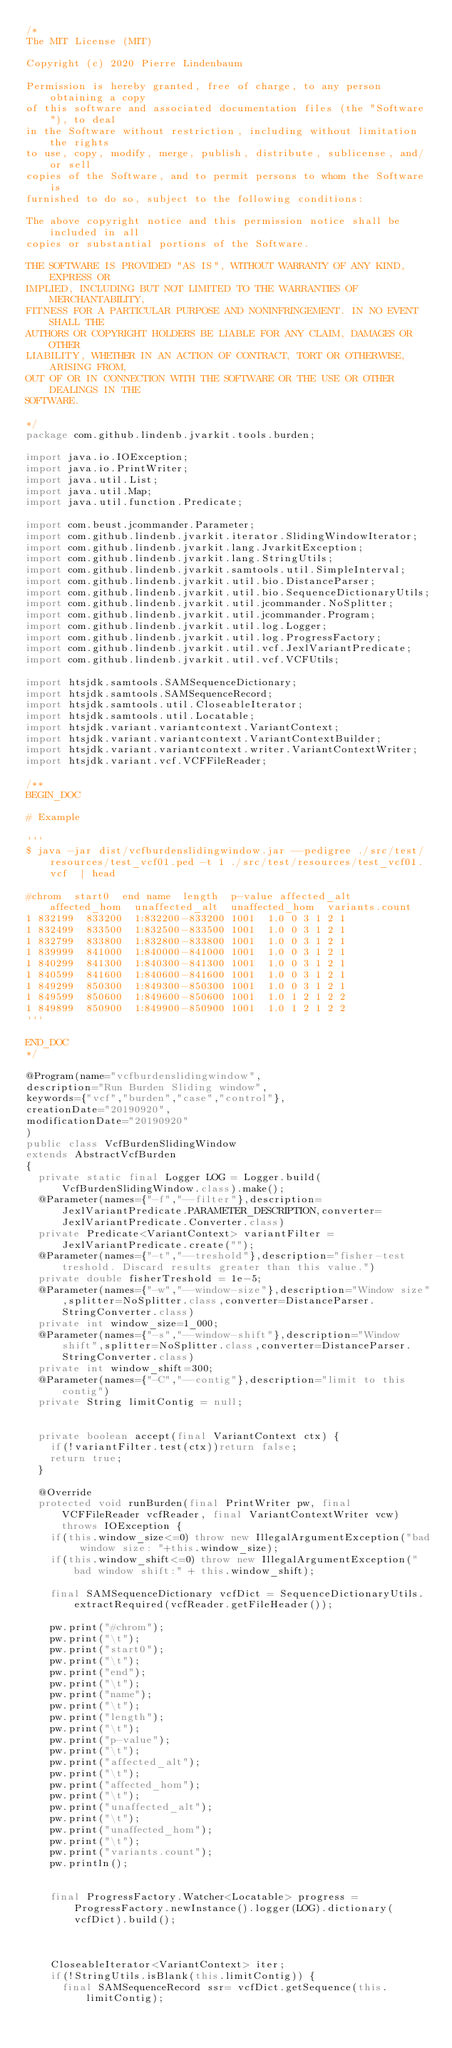<code> <loc_0><loc_0><loc_500><loc_500><_Java_>/*
The MIT License (MIT)

Copyright (c) 2020 Pierre Lindenbaum

Permission is hereby granted, free of charge, to any person obtaining a copy
of this software and associated documentation files (the "Software"), to deal
in the Software without restriction, including without limitation the rights
to use, copy, modify, merge, publish, distribute, sublicense, and/or sell
copies of the Software, and to permit persons to whom the Software is
furnished to do so, subject to the following conditions:

The above copyright notice and this permission notice shall be included in all
copies or substantial portions of the Software.

THE SOFTWARE IS PROVIDED "AS IS", WITHOUT WARRANTY OF ANY KIND, EXPRESS OR
IMPLIED, INCLUDING BUT NOT LIMITED TO THE WARRANTIES OF MERCHANTABILITY,
FITNESS FOR A PARTICULAR PURPOSE AND NONINFRINGEMENT. IN NO EVENT SHALL THE
AUTHORS OR COPYRIGHT HOLDERS BE LIABLE FOR ANY CLAIM, DAMAGES OR OTHER
LIABILITY, WHETHER IN AN ACTION OF CONTRACT, TORT OR OTHERWISE, ARISING FROM,
OUT OF OR IN CONNECTION WITH THE SOFTWARE OR THE USE OR OTHER DEALINGS IN THE
SOFTWARE.

*/
package com.github.lindenb.jvarkit.tools.burden;

import java.io.IOException;
import java.io.PrintWriter;
import java.util.List;
import java.util.Map;
import java.util.function.Predicate;

import com.beust.jcommander.Parameter;
import com.github.lindenb.jvarkit.iterator.SlidingWindowIterator;
import com.github.lindenb.jvarkit.lang.JvarkitException;
import com.github.lindenb.jvarkit.lang.StringUtils;
import com.github.lindenb.jvarkit.samtools.util.SimpleInterval;
import com.github.lindenb.jvarkit.util.bio.DistanceParser;
import com.github.lindenb.jvarkit.util.bio.SequenceDictionaryUtils;
import com.github.lindenb.jvarkit.util.jcommander.NoSplitter;
import com.github.lindenb.jvarkit.util.jcommander.Program;
import com.github.lindenb.jvarkit.util.log.Logger;
import com.github.lindenb.jvarkit.util.log.ProgressFactory;
import com.github.lindenb.jvarkit.util.vcf.JexlVariantPredicate;
import com.github.lindenb.jvarkit.util.vcf.VCFUtils;

import htsjdk.samtools.SAMSequenceDictionary;
import htsjdk.samtools.SAMSequenceRecord;
import htsjdk.samtools.util.CloseableIterator;
import htsjdk.samtools.util.Locatable;
import htsjdk.variant.variantcontext.VariantContext;
import htsjdk.variant.variantcontext.VariantContextBuilder;
import htsjdk.variant.variantcontext.writer.VariantContextWriter;
import htsjdk.variant.vcf.VCFFileReader;

/**
BEGIN_DOC

# Example

```
$ java -jar dist/vcfburdenslidingwindow.jar --pedigree ./src/test/resources/test_vcf01.ped -t 1 ./src/test/resources/test_vcf01.vcf  | head

#chrom	start0	end	name	length	p-value	affected_alt	affected_hom	unaffected_alt	unaffected_hom	variants.count
1	832199	833200	1:832200-833200	1001	1.0	0	3	1	2	1
1	832499	833500	1:832500-833500	1001	1.0	0	3	1	2	1
1	832799	833800	1:832800-833800	1001	1.0	0	3	1	2	1
1	839999	841000	1:840000-841000	1001	1.0	0	3	1	2	1
1	840299	841300	1:840300-841300	1001	1.0	0	3	1	2	1
1	840599	841600	1:840600-841600	1001	1.0	0	3	1	2	1
1	849299	850300	1:849300-850300	1001	1.0	0	3	1	2	1
1	849599	850600	1:849600-850600	1001	1.0	1	2	1	2	2
1	849899	850900	1:849900-850900	1001	1.0	1	2	1	2	2
```

END_DOC
*/

@Program(name="vcfburdenslidingwindow",
description="Run Burden Sliding window",
keywords={"vcf","burden","case","control"},
creationDate="20190920",
modificationDate="20190920"
)
public class VcfBurdenSlidingWindow
extends AbstractVcfBurden
{
	private static final Logger LOG = Logger.build(VcfBurdenSlidingWindow.class).make();
	@Parameter(names={"-f","--filter"},description=JexlVariantPredicate.PARAMETER_DESCRIPTION,converter=JexlVariantPredicate.Converter.class)
	private Predicate<VariantContext> variantFilter = JexlVariantPredicate.create("");
	@Parameter(names={"-t","--treshold"},description="fisher-test treshold. Discard results greater than this value.")
	private double fisherTreshold = 1e-5;
	@Parameter(names={"-w","--window-size"},description="Window size",splitter=NoSplitter.class,converter=DistanceParser.StringConverter.class)
	private int window_size=1_000;
	@Parameter(names={"-s","--window-shift"},description="Window shift",splitter=NoSplitter.class,converter=DistanceParser.StringConverter.class)
	private int window_shift=300;
	@Parameter(names={"-C","--contig"},description="limit to this contig")
	private String limitContig = null;


	private boolean accept(final VariantContext ctx) {
		if(!variantFilter.test(ctx))return false;
		return true;
	}

	@Override
	protected void runBurden(final PrintWriter pw, final VCFFileReader vcfReader, final VariantContextWriter vcw) throws IOException {
		if(this.window_size<=0) throw new IllegalArgumentException("bad window size: "+this.window_size);
		if(this.window_shift<=0) throw new IllegalArgumentException("bad window shift:" + this.window_shift);
		
		final SAMSequenceDictionary vcfDict = SequenceDictionaryUtils.extractRequired(vcfReader.getFileHeader());
		
		pw.print("#chrom");
		pw.print("\t");
		pw.print("start0");
		pw.print("\t");
		pw.print("end");
		pw.print("\t");
		pw.print("name");
		pw.print("\t");
		pw.print("length");
		pw.print("\t");
		pw.print("p-value");
		pw.print("\t");
		pw.print("affected_alt");
		pw.print("\t");
		pw.print("affected_hom");
		pw.print("\t");
		pw.print("unaffected_alt");
		pw.print("\t");
		pw.print("unaffected_hom");
		pw.print("\t");
		pw.print("variants.count");
		pw.println();

		
		final ProgressFactory.Watcher<Locatable> progress = ProgressFactory.newInstance().logger(LOG).dictionary(vcfDict).build();
		
		
		
		CloseableIterator<VariantContext> iter;
		if(!StringUtils.isBlank(this.limitContig)) {
			final SAMSequenceRecord ssr= vcfDict.getSequence(this.limitContig);</code> 